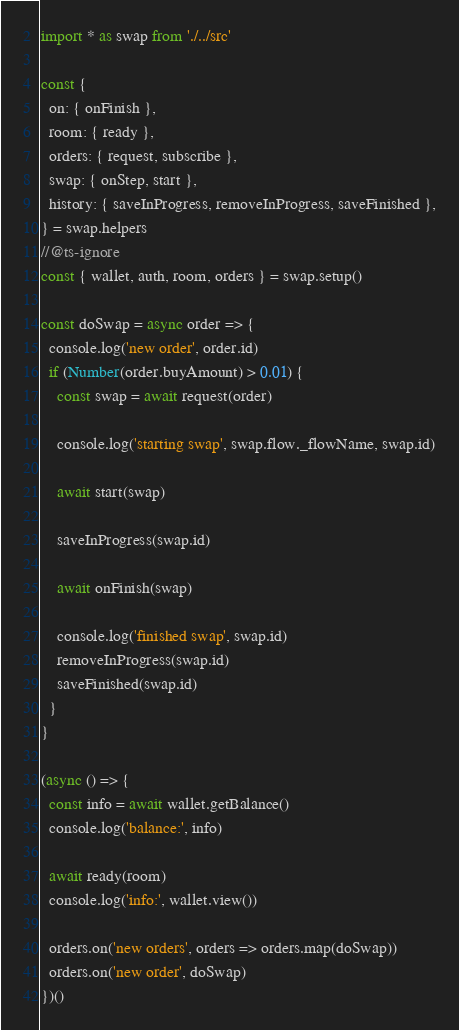<code> <loc_0><loc_0><loc_500><loc_500><_TypeScript_>import * as swap from './../src'

const {
  on: { onFinish },
  room: { ready },
  orders: { request, subscribe },
  swap: { onStep, start },
  history: { saveInProgress, removeInProgress, saveFinished },
} = swap.helpers
//@ts-ignore
const { wallet, auth, room, orders } = swap.setup()

const doSwap = async order => {
  console.log('new order', order.id)
  if (Number(order.buyAmount) > 0.01) {
    const swap = await request(order)

    console.log('starting swap', swap.flow._flowName, swap.id)

    await start(swap)

    saveInProgress(swap.id)

    await onFinish(swap)

    console.log('finished swap', swap.id)
    removeInProgress(swap.id)
    saveFinished(swap.id)
  }
}

(async () => {
  const info = await wallet.getBalance()
  console.log('balance:', info)

  await ready(room)
  console.log('info:', wallet.view())

  orders.on('new orders', orders => orders.map(doSwap))
  orders.on('new order', doSwap)
})()
</code> 